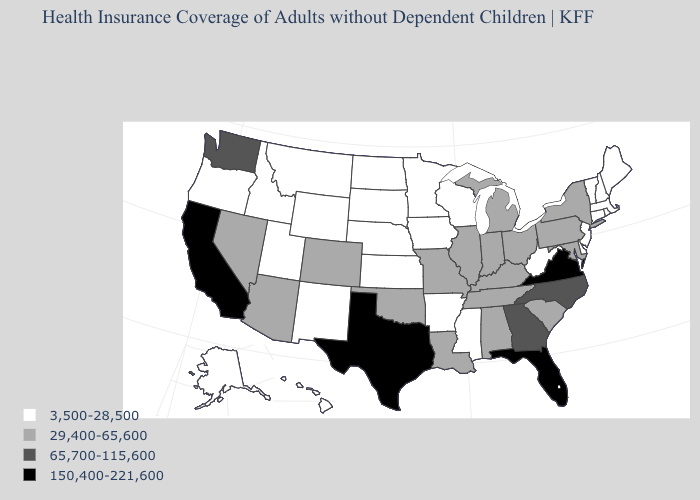Name the states that have a value in the range 29,400-65,600?
Answer briefly. Alabama, Arizona, Colorado, Illinois, Indiana, Kentucky, Louisiana, Maryland, Michigan, Missouri, Nevada, New York, Ohio, Oklahoma, Pennsylvania, South Carolina, Tennessee. What is the lowest value in the USA?
Be succinct. 3,500-28,500. Does Michigan have a higher value than Illinois?
Concise answer only. No. Does New Jersey have the same value as Arkansas?
Keep it brief. Yes. Among the states that border Iowa , does Illinois have the highest value?
Quick response, please. Yes. Among the states that border New York , does Pennsylvania have the highest value?
Keep it brief. Yes. Among the states that border Connecticut , which have the lowest value?
Concise answer only. Massachusetts, Rhode Island. What is the lowest value in the MidWest?
Short answer required. 3,500-28,500. Name the states that have a value in the range 65,700-115,600?
Give a very brief answer. Georgia, North Carolina, Washington. Which states have the lowest value in the USA?
Quick response, please. Alaska, Arkansas, Connecticut, Delaware, Hawaii, Idaho, Iowa, Kansas, Maine, Massachusetts, Minnesota, Mississippi, Montana, Nebraska, New Hampshire, New Jersey, New Mexico, North Dakota, Oregon, Rhode Island, South Dakota, Utah, Vermont, West Virginia, Wisconsin, Wyoming. Name the states that have a value in the range 3,500-28,500?
Write a very short answer. Alaska, Arkansas, Connecticut, Delaware, Hawaii, Idaho, Iowa, Kansas, Maine, Massachusetts, Minnesota, Mississippi, Montana, Nebraska, New Hampshire, New Jersey, New Mexico, North Dakota, Oregon, Rhode Island, South Dakota, Utah, Vermont, West Virginia, Wisconsin, Wyoming. Which states have the lowest value in the Northeast?
Answer briefly. Connecticut, Maine, Massachusetts, New Hampshire, New Jersey, Rhode Island, Vermont. What is the highest value in the MidWest ?
Keep it brief. 29,400-65,600. Which states have the highest value in the USA?
Concise answer only. California, Florida, Texas, Virginia. Which states have the lowest value in the USA?
Answer briefly. Alaska, Arkansas, Connecticut, Delaware, Hawaii, Idaho, Iowa, Kansas, Maine, Massachusetts, Minnesota, Mississippi, Montana, Nebraska, New Hampshire, New Jersey, New Mexico, North Dakota, Oregon, Rhode Island, South Dakota, Utah, Vermont, West Virginia, Wisconsin, Wyoming. 